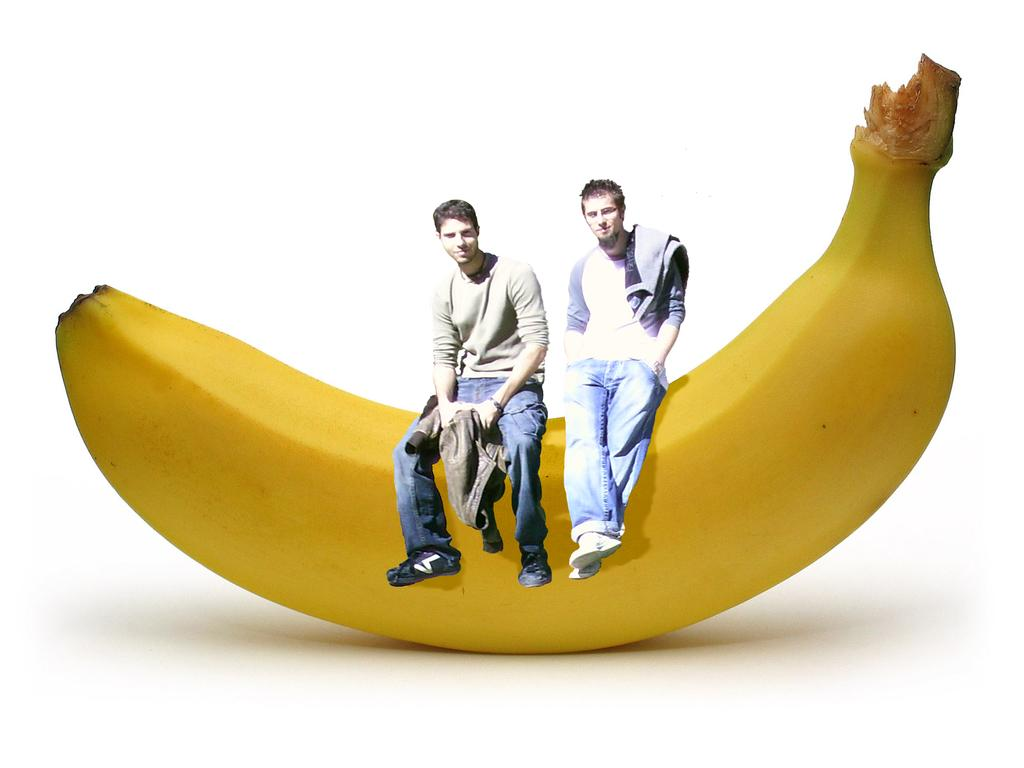How many people are in the image? There are two people in the image. What are the people doing in the image? The two people are sitting on a banana. What can be observed about the clothing of the people in the image? The people are wearing different color dresses. What is the color of the background in the image? The background of the image is white. Can you tell me how many docks are visible in the image? There are no docks present in the image. What type of quiver is being used by the people in the image? There is no quiver present in the image. 